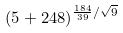<formula> <loc_0><loc_0><loc_500><loc_500>( 5 + 2 4 8 ) ^ { \frac { 1 8 4 } { 3 9 } / \sqrt { 9 } }</formula> 